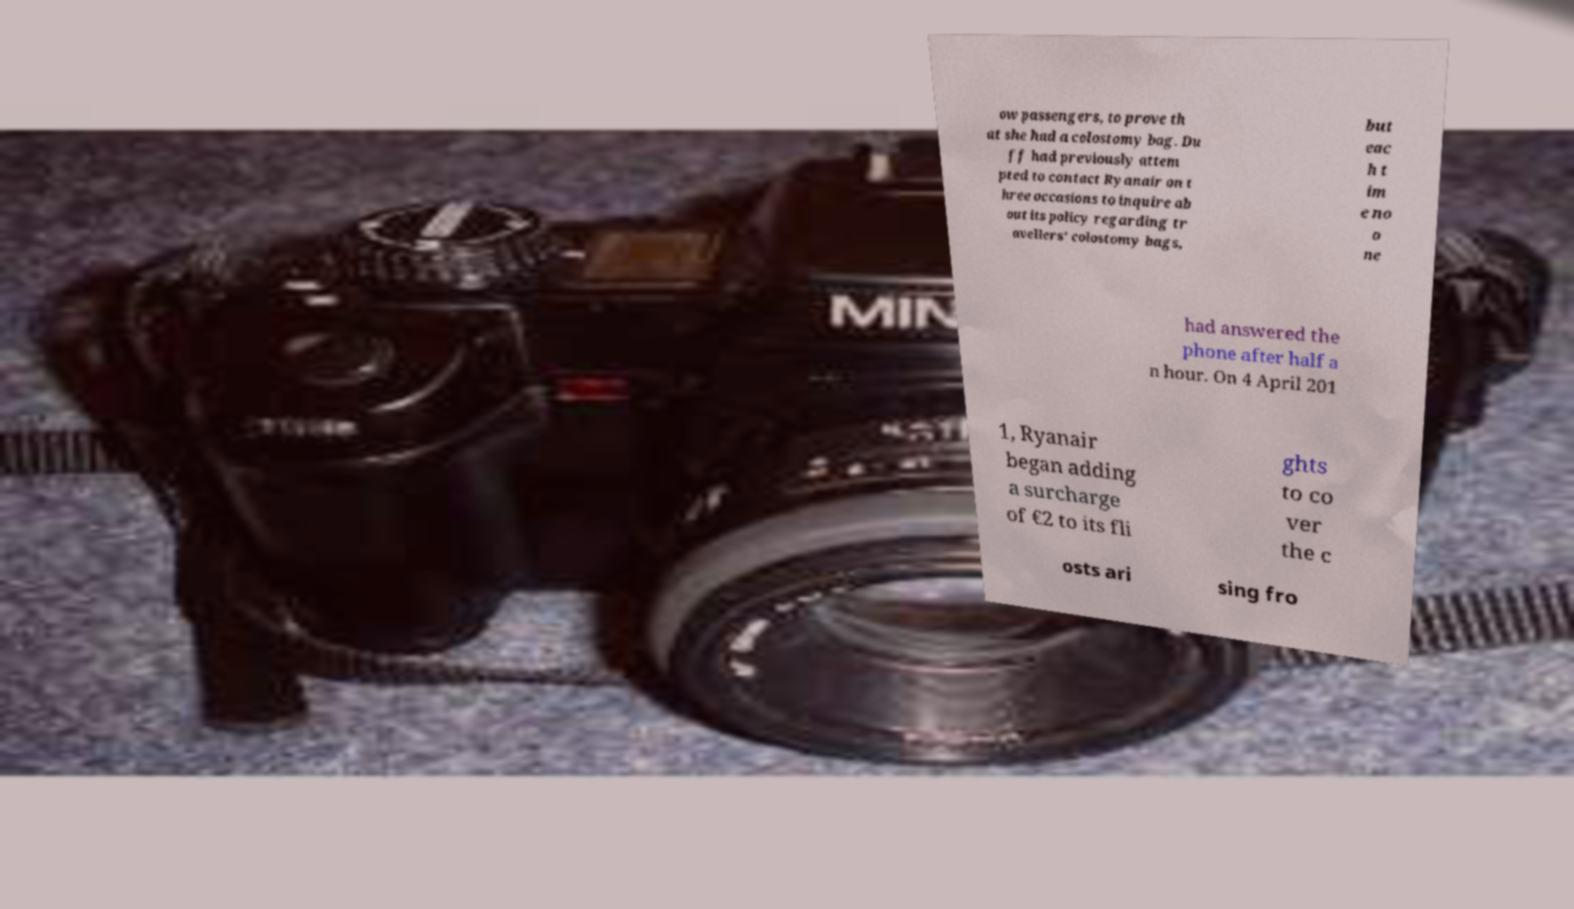Can you read and provide the text displayed in the image?This photo seems to have some interesting text. Can you extract and type it out for me? ow passengers, to prove th at she had a colostomy bag. Du ff had previously attem pted to contact Ryanair on t hree occasions to inquire ab out its policy regarding tr avellers' colostomy bags, but eac h t im e no o ne had answered the phone after half a n hour. On 4 April 201 1, Ryanair began adding a surcharge of €2 to its fli ghts to co ver the c osts ari sing fro 